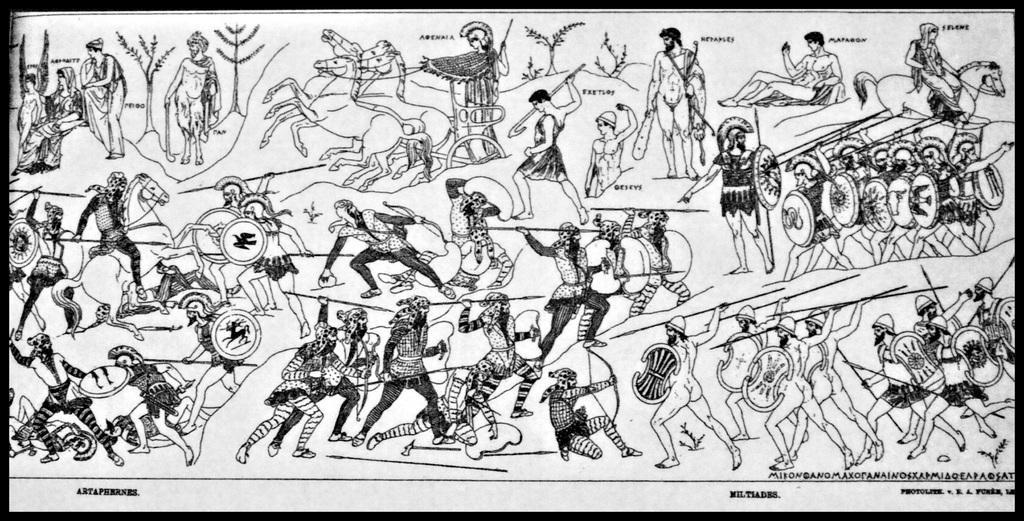In one or two sentences, can you explain what this image depicts? This image is a black and white image. This image consists of a poster with many images of humans and horses and there is a text on it. 